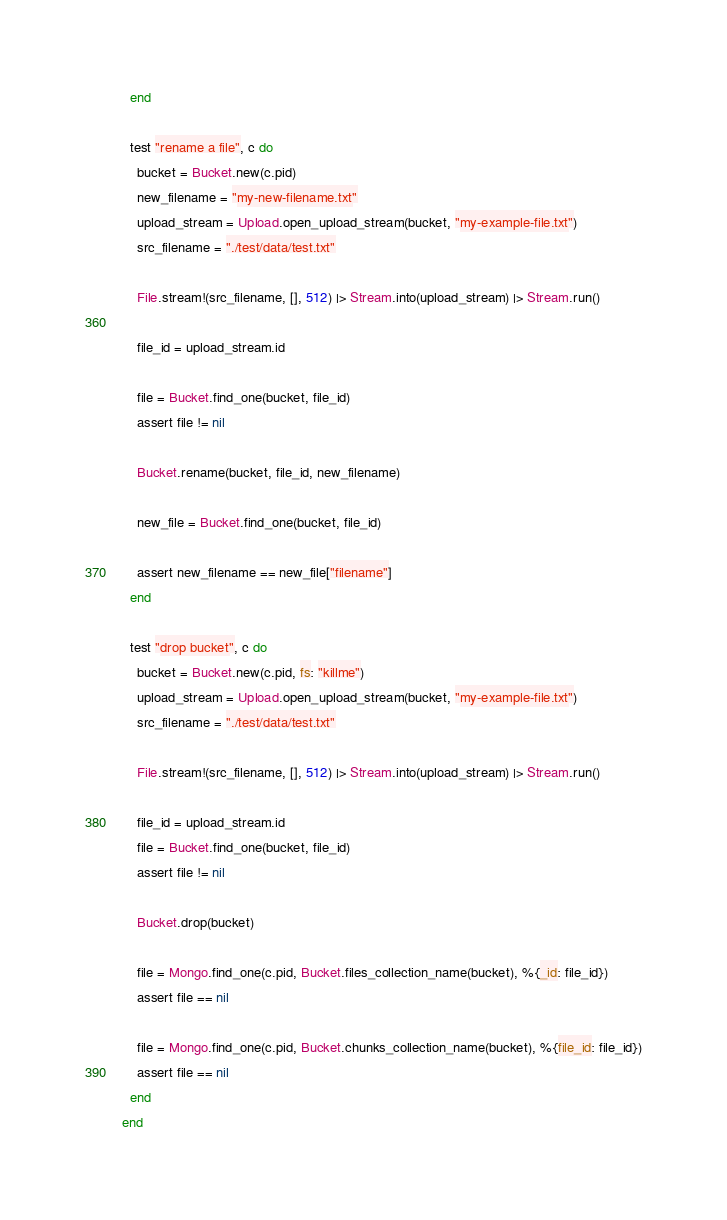Convert code to text. <code><loc_0><loc_0><loc_500><loc_500><_Elixir_>  end

  test "rename a file", c do
    bucket = Bucket.new(c.pid)
    new_filename = "my-new-filename.txt"
    upload_stream = Upload.open_upload_stream(bucket, "my-example-file.txt")
    src_filename = "./test/data/test.txt"

    File.stream!(src_filename, [], 512) |> Stream.into(upload_stream) |> Stream.run()

    file_id = upload_stream.id

    file = Bucket.find_one(bucket, file_id)
    assert file != nil

    Bucket.rename(bucket, file_id, new_filename)

    new_file = Bucket.find_one(bucket, file_id)

    assert new_filename == new_file["filename"]
  end

  test "drop bucket", c do
    bucket = Bucket.new(c.pid, fs: "killme")
    upload_stream = Upload.open_upload_stream(bucket, "my-example-file.txt")
    src_filename = "./test/data/test.txt"

    File.stream!(src_filename, [], 512) |> Stream.into(upload_stream) |> Stream.run()

    file_id = upload_stream.id
    file = Bucket.find_one(bucket, file_id)
    assert file != nil

    Bucket.drop(bucket)

    file = Mongo.find_one(c.pid, Bucket.files_collection_name(bucket), %{_id: file_id})
    assert file == nil

    file = Mongo.find_one(c.pid, Bucket.chunks_collection_name(bucket), %{file_id: file_id})
    assert file == nil
  end
end
</code> 